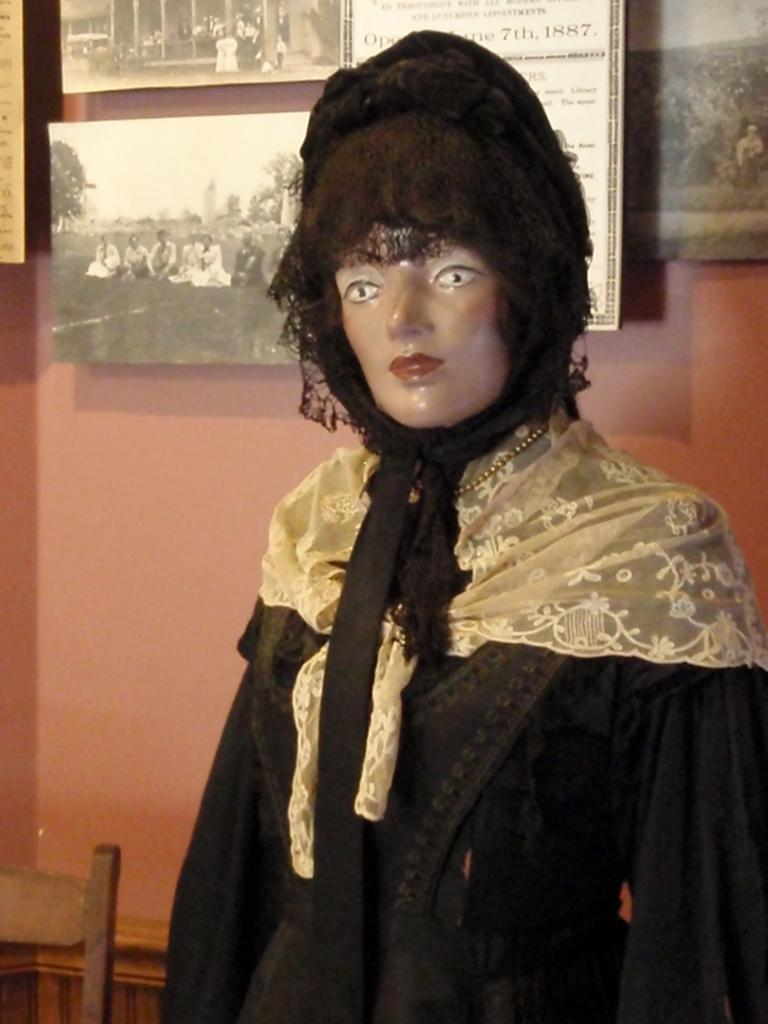What is the main subject of the image? There is a depiction of women in the center of the image. What can be seen in the background of the image? There is a wall in the background of the image. What type of cheese is being used to create the language in the image? There is no cheese or language present in the image; it features a depiction of women and a wall in the background. 